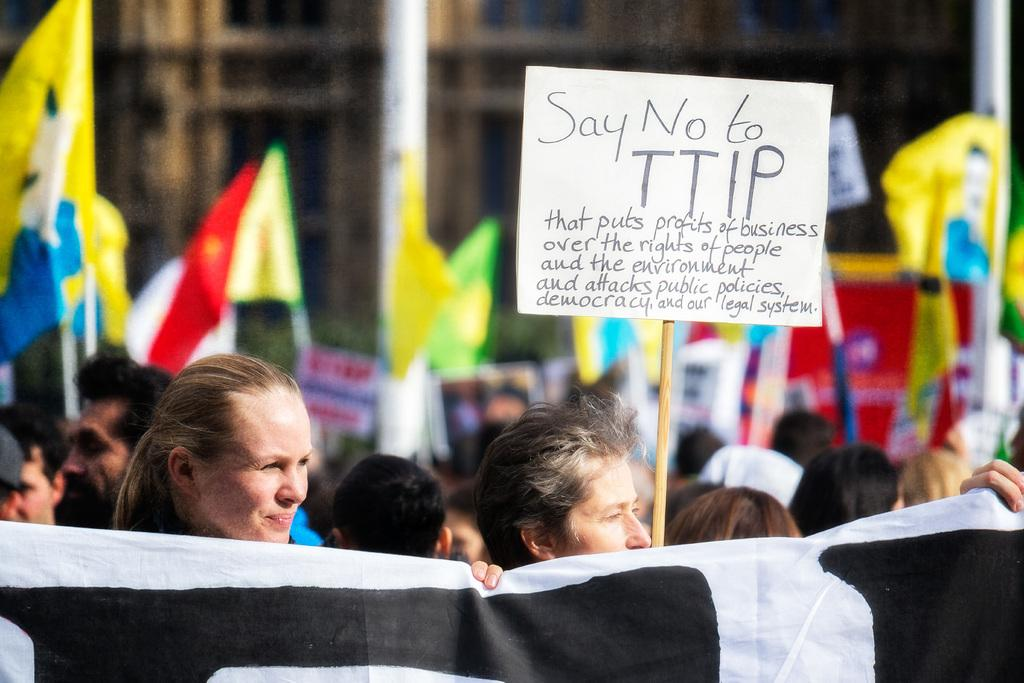How many people are in the image? There is a group of people in the image, but the exact number cannot be determined from the provided facts. What is hanging in the image? There is a banner and flags in the image. What is written or displayed on a surface in the image? There is a board with text in the image. What object can be seen in the image that is typically used for support or leverage? There is a stick in the image. What is the background of the image like? The background of the image has a blurred view. What type of structures can be seen in the image? There are buildings in the image. Where is the restroom located in the image? There is no mention of a restroom in the image or the provided facts. What type of carriage is present in the image? There is no carriage present in the image. 